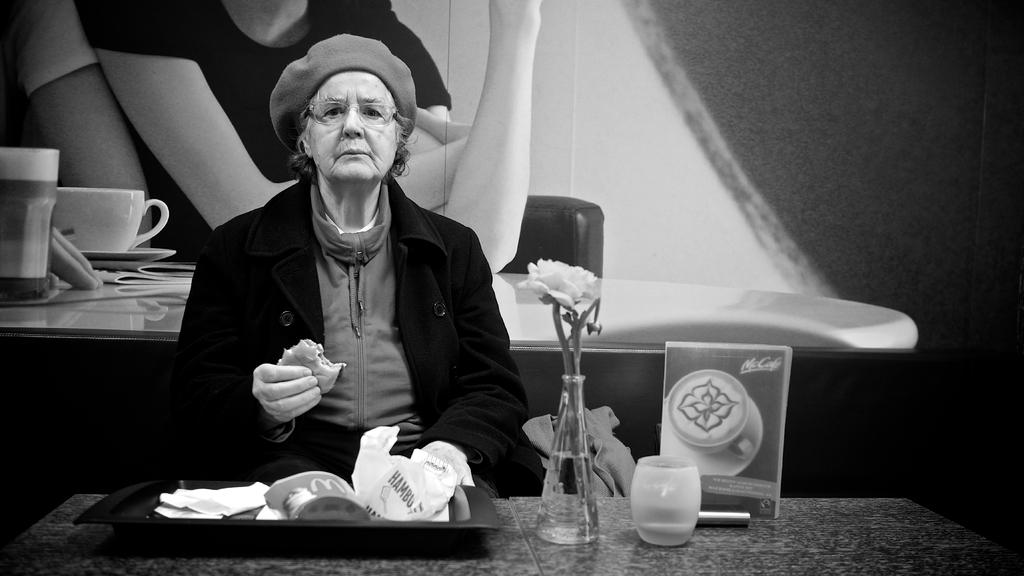Who is the main subject in the image? There is an old woman in the image. What is the old woman doing in the image? The old woman is eating in the image. What is on the table in the image? There is a tray on the table in the image. Can you describe any other objects in the image? There is a flower vase in the image. What type of fan is visible in the image? There is no fan present in the image. 